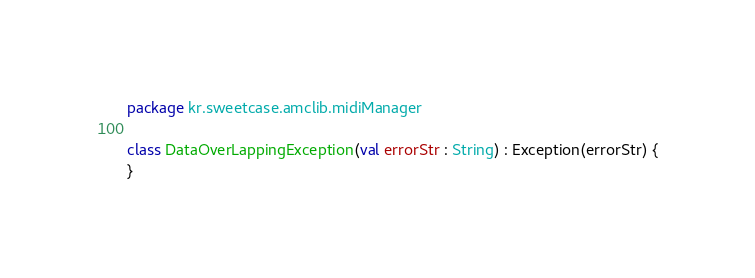<code> <loc_0><loc_0><loc_500><loc_500><_Kotlin_>package kr.sweetcase.amclib.midiManager

class DataOverLappingException(val errorStr : String) : Exception(errorStr) {
}</code> 